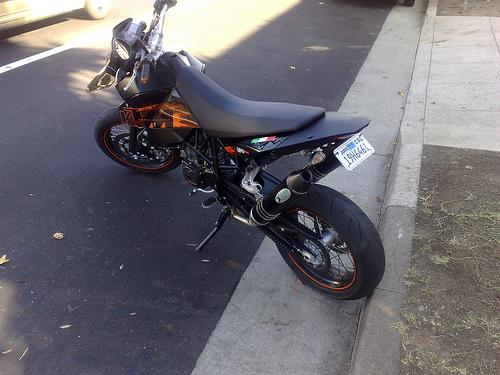Mention any distinctive elements on the motorcycle's wheels and seat. There is an orange stripe on the rim, and the seat is black. Describe the condition of the grass near the motorcycle and the state of the motorcycle's kickstand. There is dead grass and dirt near the motorcycle, and the kickstand is down. What is the design on the motorcycle and what color is it? Also, mention the handlebar tip color. The design on the motorcycle is orange, and the handlebar tip is also orange. Name the primary object in the image and its color. The primary object in the image is a motorcycle, and it is black. Identify the object that the motorcycle is parked next to. The motorcycle is parked next to a curb. Choose the best task: Provide information about the motorcycle's license plate and tires. Referential Expression Grounding Task Select the appropriate task: Is the motorcycle made by KTM and does it have a specific color design? Visual Entailment Task In a few words, describe the overall appearance of the motorcycle, its manufacturer, and details about its parking situation. A black KTM motorcycle with orange design details is parked on the street with its kickstand down and tire against the curb. Find a featured accessory on the motorcycle and describe its origin. A flag sticker on the motorcycle is from Italy. What type of surface is the motorcycle parked on, and mention if there are any other objects parked in the background. The motorcycle is parked on parking pavement, with a car parked in the background. 